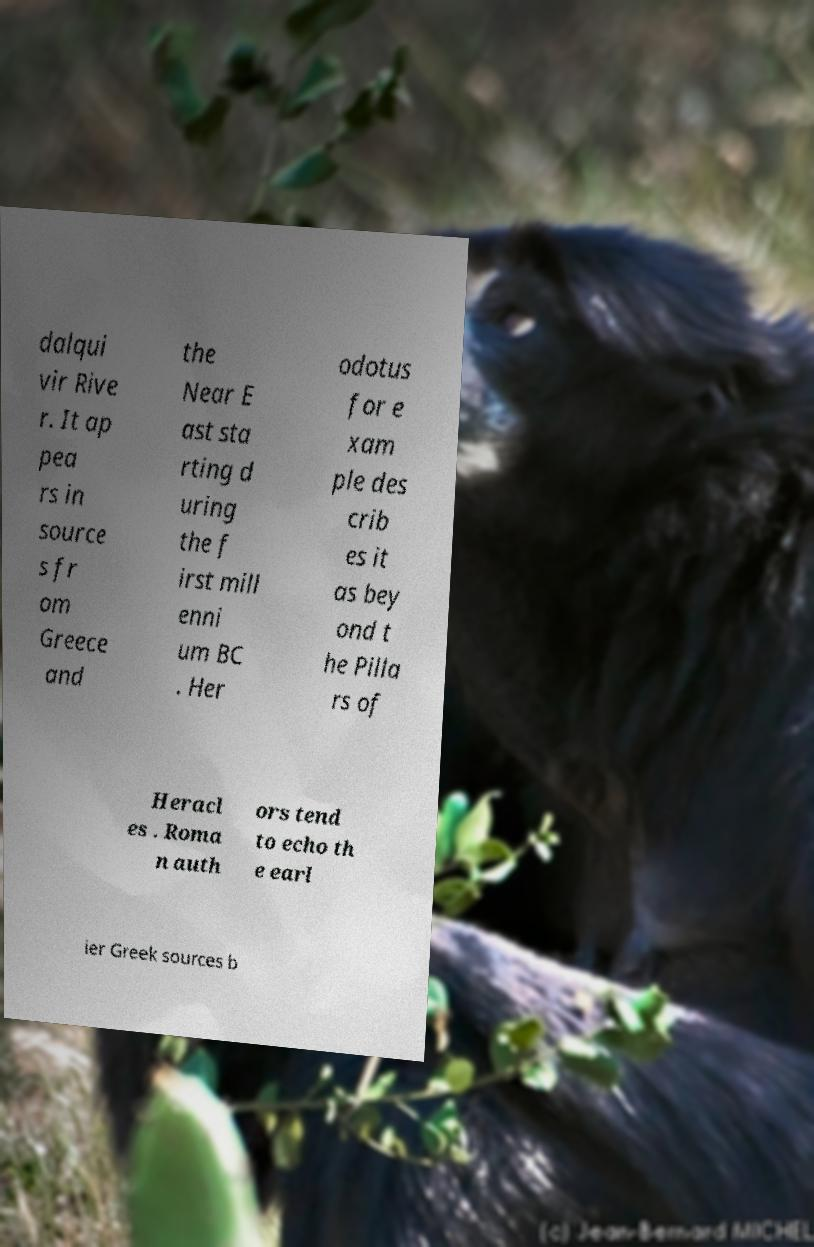Can you read and provide the text displayed in the image?This photo seems to have some interesting text. Can you extract and type it out for me? dalqui vir Rive r. It ap pea rs in source s fr om Greece and the Near E ast sta rting d uring the f irst mill enni um BC . Her odotus for e xam ple des crib es it as bey ond t he Pilla rs of Heracl es . Roma n auth ors tend to echo th e earl ier Greek sources b 